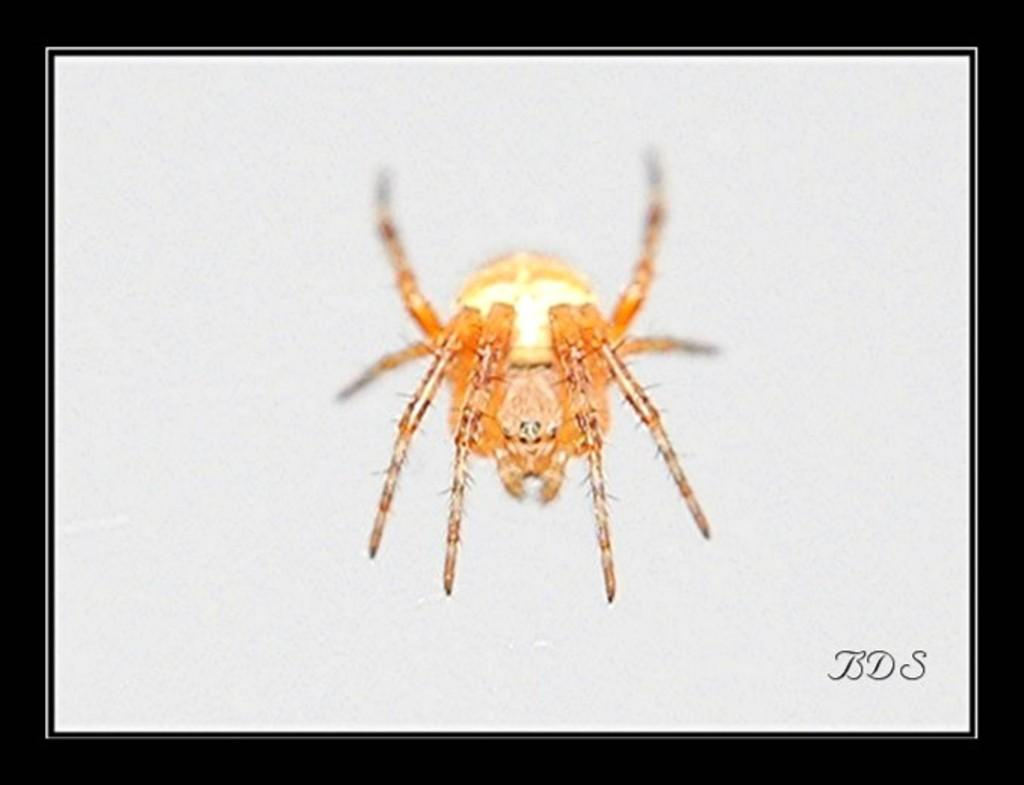What is the main subject in the center of the image? There is a spider in the center of the image. What type of creature can be seen breathing on the road in the image? There is no creature breathing on the road in the image, nor is there any road present. 